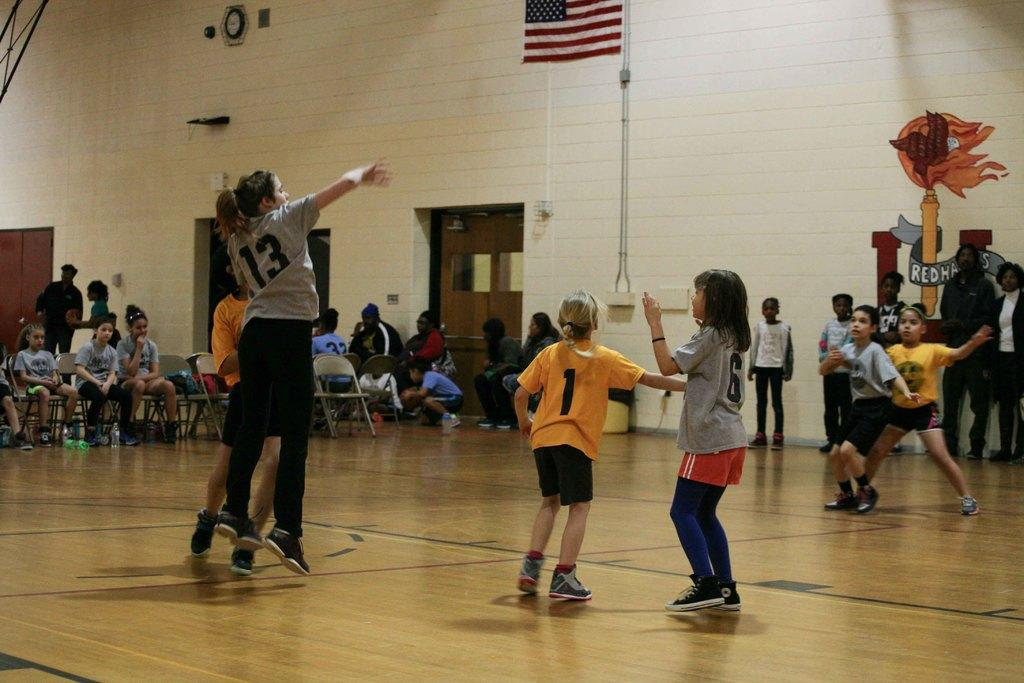What type of area is depicted in the image? There is a court in the image. How many people are present in the image? There are multiple people in the image. What can be seen in the background of the image? There is a wall in the background of the image, and doors are visible. What are some people doing in the image? Some people are sitting on chairs in the image. What type of map is being discussed by the people in the image? There is no map present in the image, and no discussion about a map is taking place. 